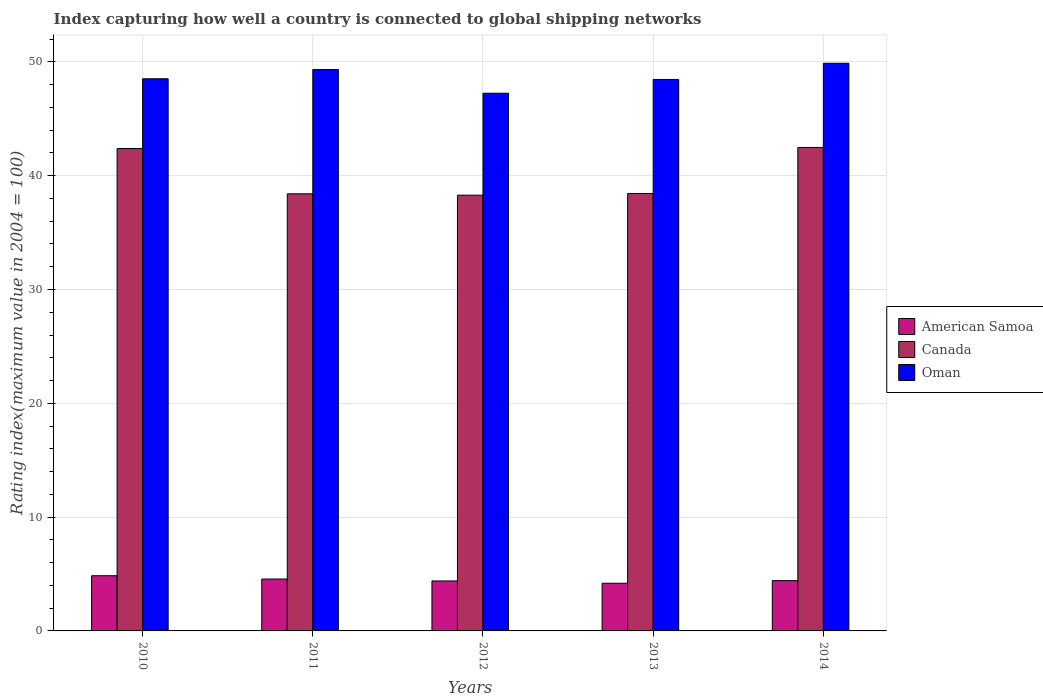Are the number of bars per tick equal to the number of legend labels?
Your answer should be compact. Yes. What is the rating index in American Samoa in 2012?
Ensure brevity in your answer.  4.39. Across all years, what is the maximum rating index in American Samoa?
Your answer should be very brief. 4.85. Across all years, what is the minimum rating index in Oman?
Your answer should be compact. 47.25. In which year was the rating index in Canada maximum?
Provide a short and direct response. 2014. In which year was the rating index in American Samoa minimum?
Ensure brevity in your answer.  2013. What is the total rating index in American Samoa in the graph?
Ensure brevity in your answer.  22.41. What is the difference between the rating index in Oman in 2010 and that in 2014?
Your answer should be compact. -1.36. What is the difference between the rating index in Oman in 2011 and the rating index in Canada in 2013?
Offer a terse response. 10.89. What is the average rating index in Oman per year?
Provide a succinct answer. 48.69. In the year 2011, what is the difference between the rating index in Canada and rating index in American Samoa?
Your answer should be compact. 33.85. What is the ratio of the rating index in Oman in 2010 to that in 2012?
Your answer should be very brief. 1.03. Is the difference between the rating index in Canada in 2011 and 2014 greater than the difference between the rating index in American Samoa in 2011 and 2014?
Offer a very short reply. No. What is the difference between the highest and the second highest rating index in Canada?
Your response must be concise. 0.09. What is the difference between the highest and the lowest rating index in Oman?
Your response must be concise. 2.63. What does the 1st bar from the left in 2014 represents?
Your response must be concise. American Samoa. Is it the case that in every year, the sum of the rating index in American Samoa and rating index in Oman is greater than the rating index in Canada?
Provide a short and direct response. Yes. How many years are there in the graph?
Your answer should be compact. 5. Does the graph contain grids?
Offer a terse response. Yes. Where does the legend appear in the graph?
Provide a short and direct response. Center right. How many legend labels are there?
Offer a terse response. 3. What is the title of the graph?
Your answer should be compact. Index capturing how well a country is connected to global shipping networks. What is the label or title of the Y-axis?
Your answer should be very brief. Rating index(maximum value in 2004 = 100). What is the Rating index(maximum value in 2004 = 100) in American Samoa in 2010?
Your answer should be very brief. 4.85. What is the Rating index(maximum value in 2004 = 100) of Canada in 2010?
Give a very brief answer. 42.39. What is the Rating index(maximum value in 2004 = 100) of Oman in 2010?
Provide a short and direct response. 48.52. What is the Rating index(maximum value in 2004 = 100) in American Samoa in 2011?
Provide a short and direct response. 4.56. What is the Rating index(maximum value in 2004 = 100) of Canada in 2011?
Provide a succinct answer. 38.41. What is the Rating index(maximum value in 2004 = 100) of Oman in 2011?
Provide a short and direct response. 49.33. What is the Rating index(maximum value in 2004 = 100) in American Samoa in 2012?
Your answer should be very brief. 4.39. What is the Rating index(maximum value in 2004 = 100) of Canada in 2012?
Give a very brief answer. 38.29. What is the Rating index(maximum value in 2004 = 100) of Oman in 2012?
Your response must be concise. 47.25. What is the Rating index(maximum value in 2004 = 100) in American Samoa in 2013?
Provide a succinct answer. 4.19. What is the Rating index(maximum value in 2004 = 100) of Canada in 2013?
Make the answer very short. 38.44. What is the Rating index(maximum value in 2004 = 100) in Oman in 2013?
Provide a short and direct response. 48.46. What is the Rating index(maximum value in 2004 = 100) of American Samoa in 2014?
Provide a short and direct response. 4.42. What is the Rating index(maximum value in 2004 = 100) in Canada in 2014?
Offer a terse response. 42.48. What is the Rating index(maximum value in 2004 = 100) of Oman in 2014?
Your answer should be very brief. 49.88. Across all years, what is the maximum Rating index(maximum value in 2004 = 100) of American Samoa?
Offer a very short reply. 4.85. Across all years, what is the maximum Rating index(maximum value in 2004 = 100) of Canada?
Provide a succinct answer. 42.48. Across all years, what is the maximum Rating index(maximum value in 2004 = 100) in Oman?
Your answer should be compact. 49.88. Across all years, what is the minimum Rating index(maximum value in 2004 = 100) in American Samoa?
Provide a succinct answer. 4.19. Across all years, what is the minimum Rating index(maximum value in 2004 = 100) of Canada?
Provide a succinct answer. 38.29. Across all years, what is the minimum Rating index(maximum value in 2004 = 100) in Oman?
Your answer should be very brief. 47.25. What is the total Rating index(maximum value in 2004 = 100) in American Samoa in the graph?
Give a very brief answer. 22.41. What is the total Rating index(maximum value in 2004 = 100) in Canada in the graph?
Offer a very short reply. 200.01. What is the total Rating index(maximum value in 2004 = 100) in Oman in the graph?
Offer a very short reply. 243.44. What is the difference between the Rating index(maximum value in 2004 = 100) in American Samoa in 2010 and that in 2011?
Make the answer very short. 0.29. What is the difference between the Rating index(maximum value in 2004 = 100) of Canada in 2010 and that in 2011?
Make the answer very short. 3.98. What is the difference between the Rating index(maximum value in 2004 = 100) in Oman in 2010 and that in 2011?
Provide a short and direct response. -0.81. What is the difference between the Rating index(maximum value in 2004 = 100) of American Samoa in 2010 and that in 2012?
Give a very brief answer. 0.46. What is the difference between the Rating index(maximum value in 2004 = 100) of Oman in 2010 and that in 2012?
Give a very brief answer. 1.27. What is the difference between the Rating index(maximum value in 2004 = 100) of American Samoa in 2010 and that in 2013?
Give a very brief answer. 0.66. What is the difference between the Rating index(maximum value in 2004 = 100) in Canada in 2010 and that in 2013?
Your answer should be very brief. 3.95. What is the difference between the Rating index(maximum value in 2004 = 100) in Oman in 2010 and that in 2013?
Make the answer very short. 0.06. What is the difference between the Rating index(maximum value in 2004 = 100) in American Samoa in 2010 and that in 2014?
Make the answer very short. 0.43. What is the difference between the Rating index(maximum value in 2004 = 100) in Canada in 2010 and that in 2014?
Provide a short and direct response. -0.09. What is the difference between the Rating index(maximum value in 2004 = 100) of Oman in 2010 and that in 2014?
Provide a short and direct response. -1.36. What is the difference between the Rating index(maximum value in 2004 = 100) in American Samoa in 2011 and that in 2012?
Make the answer very short. 0.17. What is the difference between the Rating index(maximum value in 2004 = 100) in Canada in 2011 and that in 2012?
Your answer should be very brief. 0.12. What is the difference between the Rating index(maximum value in 2004 = 100) in Oman in 2011 and that in 2012?
Give a very brief answer. 2.08. What is the difference between the Rating index(maximum value in 2004 = 100) in American Samoa in 2011 and that in 2013?
Offer a terse response. 0.37. What is the difference between the Rating index(maximum value in 2004 = 100) of Canada in 2011 and that in 2013?
Offer a terse response. -0.03. What is the difference between the Rating index(maximum value in 2004 = 100) of Oman in 2011 and that in 2013?
Provide a succinct answer. 0.87. What is the difference between the Rating index(maximum value in 2004 = 100) in American Samoa in 2011 and that in 2014?
Give a very brief answer. 0.14. What is the difference between the Rating index(maximum value in 2004 = 100) of Canada in 2011 and that in 2014?
Offer a terse response. -4.07. What is the difference between the Rating index(maximum value in 2004 = 100) in Oman in 2011 and that in 2014?
Provide a succinct answer. -0.55. What is the difference between the Rating index(maximum value in 2004 = 100) of Canada in 2012 and that in 2013?
Give a very brief answer. -0.15. What is the difference between the Rating index(maximum value in 2004 = 100) in Oman in 2012 and that in 2013?
Offer a very short reply. -1.21. What is the difference between the Rating index(maximum value in 2004 = 100) in American Samoa in 2012 and that in 2014?
Your response must be concise. -0.03. What is the difference between the Rating index(maximum value in 2004 = 100) in Canada in 2012 and that in 2014?
Keep it short and to the point. -4.19. What is the difference between the Rating index(maximum value in 2004 = 100) in Oman in 2012 and that in 2014?
Offer a very short reply. -2.63. What is the difference between the Rating index(maximum value in 2004 = 100) in American Samoa in 2013 and that in 2014?
Your response must be concise. -0.23. What is the difference between the Rating index(maximum value in 2004 = 100) of Canada in 2013 and that in 2014?
Your answer should be very brief. -4.04. What is the difference between the Rating index(maximum value in 2004 = 100) of Oman in 2013 and that in 2014?
Provide a short and direct response. -1.42. What is the difference between the Rating index(maximum value in 2004 = 100) of American Samoa in 2010 and the Rating index(maximum value in 2004 = 100) of Canada in 2011?
Provide a short and direct response. -33.56. What is the difference between the Rating index(maximum value in 2004 = 100) in American Samoa in 2010 and the Rating index(maximum value in 2004 = 100) in Oman in 2011?
Ensure brevity in your answer.  -44.48. What is the difference between the Rating index(maximum value in 2004 = 100) of Canada in 2010 and the Rating index(maximum value in 2004 = 100) of Oman in 2011?
Ensure brevity in your answer.  -6.94. What is the difference between the Rating index(maximum value in 2004 = 100) of American Samoa in 2010 and the Rating index(maximum value in 2004 = 100) of Canada in 2012?
Offer a terse response. -33.44. What is the difference between the Rating index(maximum value in 2004 = 100) in American Samoa in 2010 and the Rating index(maximum value in 2004 = 100) in Oman in 2012?
Provide a succinct answer. -42.4. What is the difference between the Rating index(maximum value in 2004 = 100) in Canada in 2010 and the Rating index(maximum value in 2004 = 100) in Oman in 2012?
Offer a very short reply. -4.86. What is the difference between the Rating index(maximum value in 2004 = 100) in American Samoa in 2010 and the Rating index(maximum value in 2004 = 100) in Canada in 2013?
Provide a succinct answer. -33.59. What is the difference between the Rating index(maximum value in 2004 = 100) of American Samoa in 2010 and the Rating index(maximum value in 2004 = 100) of Oman in 2013?
Offer a terse response. -43.61. What is the difference between the Rating index(maximum value in 2004 = 100) in Canada in 2010 and the Rating index(maximum value in 2004 = 100) in Oman in 2013?
Offer a very short reply. -6.07. What is the difference between the Rating index(maximum value in 2004 = 100) in American Samoa in 2010 and the Rating index(maximum value in 2004 = 100) in Canada in 2014?
Make the answer very short. -37.63. What is the difference between the Rating index(maximum value in 2004 = 100) of American Samoa in 2010 and the Rating index(maximum value in 2004 = 100) of Oman in 2014?
Your answer should be very brief. -45.03. What is the difference between the Rating index(maximum value in 2004 = 100) of Canada in 2010 and the Rating index(maximum value in 2004 = 100) of Oman in 2014?
Ensure brevity in your answer.  -7.49. What is the difference between the Rating index(maximum value in 2004 = 100) in American Samoa in 2011 and the Rating index(maximum value in 2004 = 100) in Canada in 2012?
Give a very brief answer. -33.73. What is the difference between the Rating index(maximum value in 2004 = 100) in American Samoa in 2011 and the Rating index(maximum value in 2004 = 100) in Oman in 2012?
Make the answer very short. -42.69. What is the difference between the Rating index(maximum value in 2004 = 100) in Canada in 2011 and the Rating index(maximum value in 2004 = 100) in Oman in 2012?
Ensure brevity in your answer.  -8.84. What is the difference between the Rating index(maximum value in 2004 = 100) in American Samoa in 2011 and the Rating index(maximum value in 2004 = 100) in Canada in 2013?
Keep it short and to the point. -33.88. What is the difference between the Rating index(maximum value in 2004 = 100) in American Samoa in 2011 and the Rating index(maximum value in 2004 = 100) in Oman in 2013?
Offer a terse response. -43.9. What is the difference between the Rating index(maximum value in 2004 = 100) of Canada in 2011 and the Rating index(maximum value in 2004 = 100) of Oman in 2013?
Your answer should be compact. -10.05. What is the difference between the Rating index(maximum value in 2004 = 100) of American Samoa in 2011 and the Rating index(maximum value in 2004 = 100) of Canada in 2014?
Keep it short and to the point. -37.92. What is the difference between the Rating index(maximum value in 2004 = 100) in American Samoa in 2011 and the Rating index(maximum value in 2004 = 100) in Oman in 2014?
Give a very brief answer. -45.32. What is the difference between the Rating index(maximum value in 2004 = 100) of Canada in 2011 and the Rating index(maximum value in 2004 = 100) of Oman in 2014?
Your response must be concise. -11.47. What is the difference between the Rating index(maximum value in 2004 = 100) in American Samoa in 2012 and the Rating index(maximum value in 2004 = 100) in Canada in 2013?
Provide a short and direct response. -34.05. What is the difference between the Rating index(maximum value in 2004 = 100) of American Samoa in 2012 and the Rating index(maximum value in 2004 = 100) of Oman in 2013?
Ensure brevity in your answer.  -44.07. What is the difference between the Rating index(maximum value in 2004 = 100) in Canada in 2012 and the Rating index(maximum value in 2004 = 100) in Oman in 2013?
Make the answer very short. -10.17. What is the difference between the Rating index(maximum value in 2004 = 100) of American Samoa in 2012 and the Rating index(maximum value in 2004 = 100) of Canada in 2014?
Offer a very short reply. -38.09. What is the difference between the Rating index(maximum value in 2004 = 100) of American Samoa in 2012 and the Rating index(maximum value in 2004 = 100) of Oman in 2014?
Ensure brevity in your answer.  -45.49. What is the difference between the Rating index(maximum value in 2004 = 100) in Canada in 2012 and the Rating index(maximum value in 2004 = 100) in Oman in 2014?
Ensure brevity in your answer.  -11.59. What is the difference between the Rating index(maximum value in 2004 = 100) in American Samoa in 2013 and the Rating index(maximum value in 2004 = 100) in Canada in 2014?
Provide a succinct answer. -38.29. What is the difference between the Rating index(maximum value in 2004 = 100) in American Samoa in 2013 and the Rating index(maximum value in 2004 = 100) in Oman in 2014?
Give a very brief answer. -45.69. What is the difference between the Rating index(maximum value in 2004 = 100) in Canada in 2013 and the Rating index(maximum value in 2004 = 100) in Oman in 2014?
Offer a terse response. -11.44. What is the average Rating index(maximum value in 2004 = 100) of American Samoa per year?
Offer a very short reply. 4.48. What is the average Rating index(maximum value in 2004 = 100) in Canada per year?
Provide a short and direct response. 40. What is the average Rating index(maximum value in 2004 = 100) in Oman per year?
Ensure brevity in your answer.  48.69. In the year 2010, what is the difference between the Rating index(maximum value in 2004 = 100) of American Samoa and Rating index(maximum value in 2004 = 100) of Canada?
Make the answer very short. -37.54. In the year 2010, what is the difference between the Rating index(maximum value in 2004 = 100) of American Samoa and Rating index(maximum value in 2004 = 100) of Oman?
Ensure brevity in your answer.  -43.67. In the year 2010, what is the difference between the Rating index(maximum value in 2004 = 100) of Canada and Rating index(maximum value in 2004 = 100) of Oman?
Keep it short and to the point. -6.13. In the year 2011, what is the difference between the Rating index(maximum value in 2004 = 100) in American Samoa and Rating index(maximum value in 2004 = 100) in Canada?
Provide a succinct answer. -33.85. In the year 2011, what is the difference between the Rating index(maximum value in 2004 = 100) of American Samoa and Rating index(maximum value in 2004 = 100) of Oman?
Make the answer very short. -44.77. In the year 2011, what is the difference between the Rating index(maximum value in 2004 = 100) of Canada and Rating index(maximum value in 2004 = 100) of Oman?
Keep it short and to the point. -10.92. In the year 2012, what is the difference between the Rating index(maximum value in 2004 = 100) in American Samoa and Rating index(maximum value in 2004 = 100) in Canada?
Provide a short and direct response. -33.9. In the year 2012, what is the difference between the Rating index(maximum value in 2004 = 100) in American Samoa and Rating index(maximum value in 2004 = 100) in Oman?
Provide a short and direct response. -42.86. In the year 2012, what is the difference between the Rating index(maximum value in 2004 = 100) in Canada and Rating index(maximum value in 2004 = 100) in Oman?
Provide a succinct answer. -8.96. In the year 2013, what is the difference between the Rating index(maximum value in 2004 = 100) in American Samoa and Rating index(maximum value in 2004 = 100) in Canada?
Your response must be concise. -34.25. In the year 2013, what is the difference between the Rating index(maximum value in 2004 = 100) of American Samoa and Rating index(maximum value in 2004 = 100) of Oman?
Your answer should be compact. -44.27. In the year 2013, what is the difference between the Rating index(maximum value in 2004 = 100) in Canada and Rating index(maximum value in 2004 = 100) in Oman?
Make the answer very short. -10.02. In the year 2014, what is the difference between the Rating index(maximum value in 2004 = 100) of American Samoa and Rating index(maximum value in 2004 = 100) of Canada?
Provide a succinct answer. -38.07. In the year 2014, what is the difference between the Rating index(maximum value in 2004 = 100) in American Samoa and Rating index(maximum value in 2004 = 100) in Oman?
Keep it short and to the point. -45.46. In the year 2014, what is the difference between the Rating index(maximum value in 2004 = 100) in Canada and Rating index(maximum value in 2004 = 100) in Oman?
Give a very brief answer. -7.4. What is the ratio of the Rating index(maximum value in 2004 = 100) of American Samoa in 2010 to that in 2011?
Give a very brief answer. 1.06. What is the ratio of the Rating index(maximum value in 2004 = 100) in Canada in 2010 to that in 2011?
Give a very brief answer. 1.1. What is the ratio of the Rating index(maximum value in 2004 = 100) of Oman in 2010 to that in 2011?
Provide a short and direct response. 0.98. What is the ratio of the Rating index(maximum value in 2004 = 100) in American Samoa in 2010 to that in 2012?
Your answer should be very brief. 1.1. What is the ratio of the Rating index(maximum value in 2004 = 100) in Canada in 2010 to that in 2012?
Your answer should be very brief. 1.11. What is the ratio of the Rating index(maximum value in 2004 = 100) of Oman in 2010 to that in 2012?
Make the answer very short. 1.03. What is the ratio of the Rating index(maximum value in 2004 = 100) in American Samoa in 2010 to that in 2013?
Keep it short and to the point. 1.16. What is the ratio of the Rating index(maximum value in 2004 = 100) of Canada in 2010 to that in 2013?
Your answer should be compact. 1.1. What is the ratio of the Rating index(maximum value in 2004 = 100) in Oman in 2010 to that in 2013?
Offer a terse response. 1. What is the ratio of the Rating index(maximum value in 2004 = 100) in American Samoa in 2010 to that in 2014?
Keep it short and to the point. 1.1. What is the ratio of the Rating index(maximum value in 2004 = 100) of Canada in 2010 to that in 2014?
Offer a very short reply. 1. What is the ratio of the Rating index(maximum value in 2004 = 100) of Oman in 2010 to that in 2014?
Your answer should be compact. 0.97. What is the ratio of the Rating index(maximum value in 2004 = 100) in American Samoa in 2011 to that in 2012?
Keep it short and to the point. 1.04. What is the ratio of the Rating index(maximum value in 2004 = 100) in Oman in 2011 to that in 2012?
Keep it short and to the point. 1.04. What is the ratio of the Rating index(maximum value in 2004 = 100) in American Samoa in 2011 to that in 2013?
Your response must be concise. 1.09. What is the ratio of the Rating index(maximum value in 2004 = 100) in Canada in 2011 to that in 2013?
Provide a succinct answer. 1. What is the ratio of the Rating index(maximum value in 2004 = 100) in American Samoa in 2011 to that in 2014?
Give a very brief answer. 1.03. What is the ratio of the Rating index(maximum value in 2004 = 100) of Canada in 2011 to that in 2014?
Give a very brief answer. 0.9. What is the ratio of the Rating index(maximum value in 2004 = 100) in Oman in 2011 to that in 2014?
Keep it short and to the point. 0.99. What is the ratio of the Rating index(maximum value in 2004 = 100) in American Samoa in 2012 to that in 2013?
Offer a very short reply. 1.05. What is the ratio of the Rating index(maximum value in 2004 = 100) of Canada in 2012 to that in 2013?
Provide a short and direct response. 1. What is the ratio of the Rating index(maximum value in 2004 = 100) in Oman in 2012 to that in 2013?
Your answer should be very brief. 0.97. What is the ratio of the Rating index(maximum value in 2004 = 100) of Canada in 2012 to that in 2014?
Offer a very short reply. 0.9. What is the ratio of the Rating index(maximum value in 2004 = 100) of Oman in 2012 to that in 2014?
Give a very brief answer. 0.95. What is the ratio of the Rating index(maximum value in 2004 = 100) in American Samoa in 2013 to that in 2014?
Provide a succinct answer. 0.95. What is the ratio of the Rating index(maximum value in 2004 = 100) in Canada in 2013 to that in 2014?
Offer a terse response. 0.9. What is the ratio of the Rating index(maximum value in 2004 = 100) in Oman in 2013 to that in 2014?
Your response must be concise. 0.97. What is the difference between the highest and the second highest Rating index(maximum value in 2004 = 100) in American Samoa?
Offer a terse response. 0.29. What is the difference between the highest and the second highest Rating index(maximum value in 2004 = 100) of Canada?
Provide a succinct answer. 0.09. What is the difference between the highest and the second highest Rating index(maximum value in 2004 = 100) in Oman?
Make the answer very short. 0.55. What is the difference between the highest and the lowest Rating index(maximum value in 2004 = 100) of American Samoa?
Keep it short and to the point. 0.66. What is the difference between the highest and the lowest Rating index(maximum value in 2004 = 100) in Canada?
Provide a short and direct response. 4.19. What is the difference between the highest and the lowest Rating index(maximum value in 2004 = 100) of Oman?
Give a very brief answer. 2.63. 